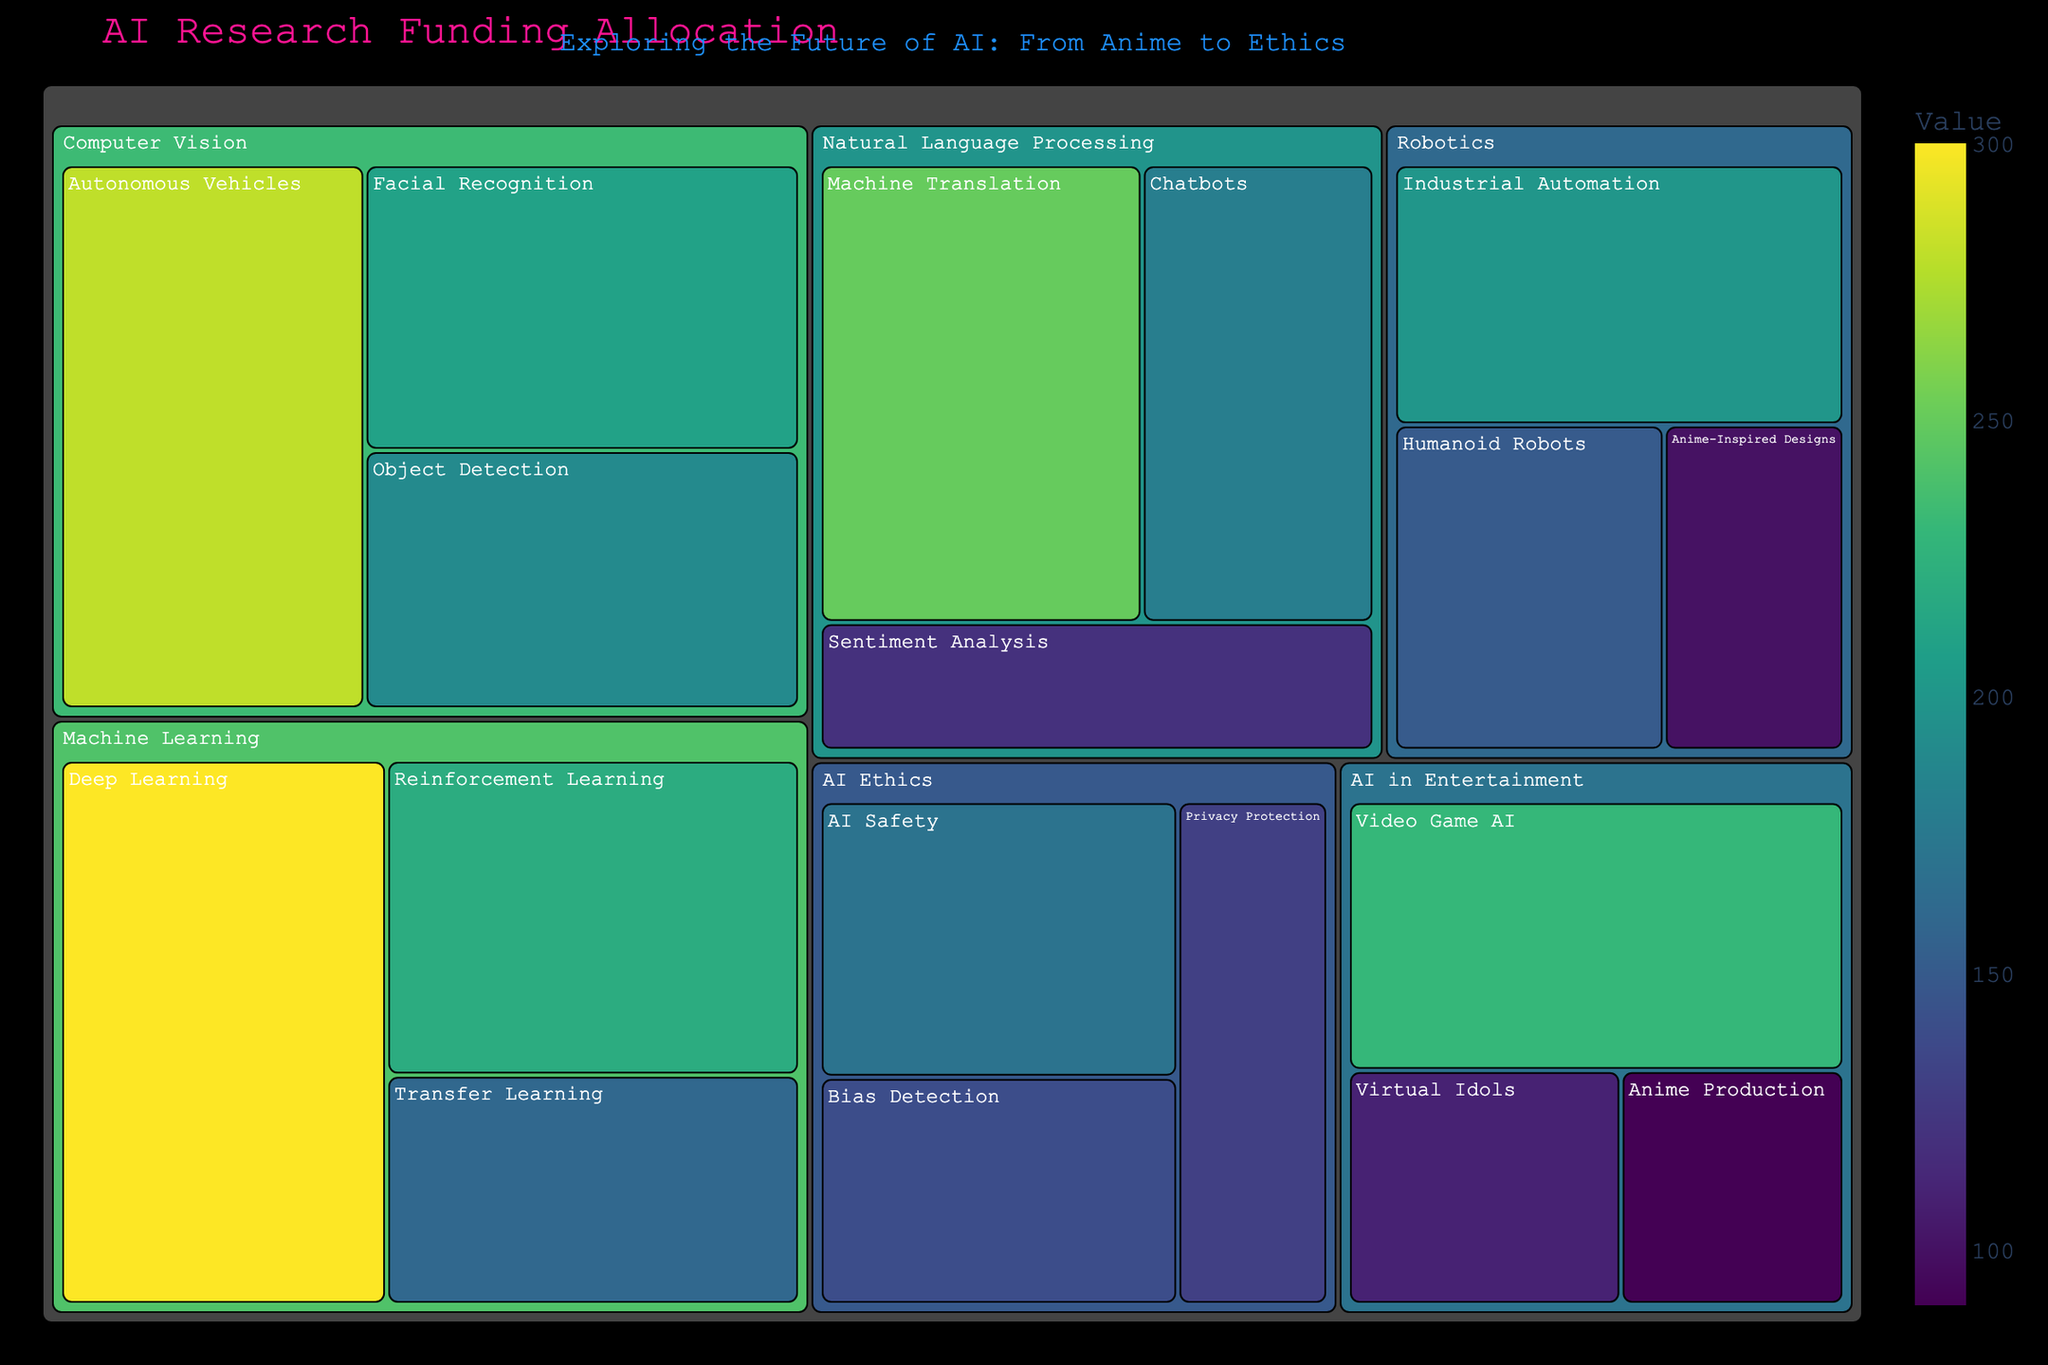What's the title of the treemap? The title is located at the top of the treemap and reads: "AI Research Funding Allocation"
Answer: AI Research Funding Allocation Which subfield under Computer Vision received the highest funding? By observing the area size representation and the numerical values on the treemap under Computer Vision, "Autonomous Vehicles" received the highest funding with a value of $280M
Answer: Autonomous Vehicles What is the combined funding allocation for the AI subfields under Natural Language Processing (NLP)? To find the total, sum the funding for all NLP subcategories: Machine Translation ($250M) + Chatbots ($180M) + Sentiment Analysis ($120M). Total = $250M + $180M + $120M = $550M
Answer: $550M How does the funding for Deep Learning compare to that of Reinforcement Learning? Both subfields are under Machine Learning. Deep Learning has a funding of $300M while Reinforcement Learning has $220M. Deep Learning received more funding.
Answer: Deep Learning received more funding Which AI Ethics subfield received the least funding? By comparing the values shown for AI Ethics subfields, Privacy Protection received $130M, which is the least among the listed subfields under AI Ethics
Answer: Privacy Protection What is the total funding allocated for Robotics? Sum up the funding for all subcategories under Robotics: Humanoid Robots ($150M) + Industrial Automation ($200M) + Anime-Inspired Designs ($100M). Total = $150M + $200M + $100M = $450M
Answer: $450M Compare the funding between AI in Entertainment and AI Ethics categories Calculate the total funding for both categories: AI in Entertainment: Video Game AI ($230M) + Virtual Idols ($110M) + Anime Production ($90M) = $430M. AI Ethics: Bias Detection ($140M) + Privacy Protection ($130M) + AI Safety ($170M) = $440M. AI Ethics has slightly more funding.
Answer: AI Ethics has slightly more funding What’s the smallest subcategory in terms of funding within the AI in Entertainment category? By looking at the subcategories within AI in Entertainment, Anime Production has the smallest funding amounting to $90M
Answer: Anime Production Which category received the highest funding overall? By comparing the summed values of all primary categories, Machine Learning stands out with the highest total: Deep Learning ($300M) + Reinforcement Learning ($220M) + Transfer Learning ($160M) = $680M
Answer: Machine Learning If the funding for Sentiment Analysis was increased by $100M, would it surpass the funding for Video Game AI? Sentiment Analysis currently receives $120M. Increasing by $100M results in $220M, which is still not more than Video Game AI's $230M
Answer: No 